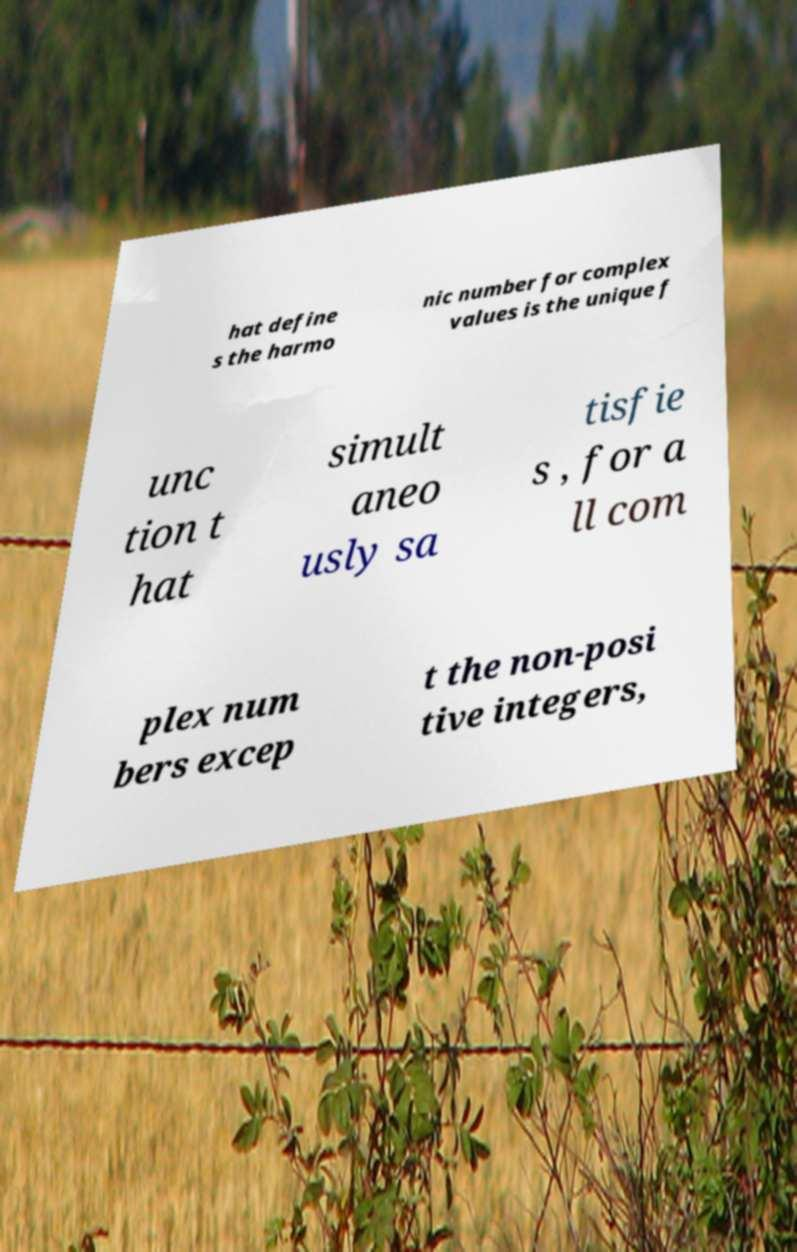There's text embedded in this image that I need extracted. Can you transcribe it verbatim? hat define s the harmo nic number for complex values is the unique f unc tion t hat simult aneo usly sa tisfie s , for a ll com plex num bers excep t the non-posi tive integers, 